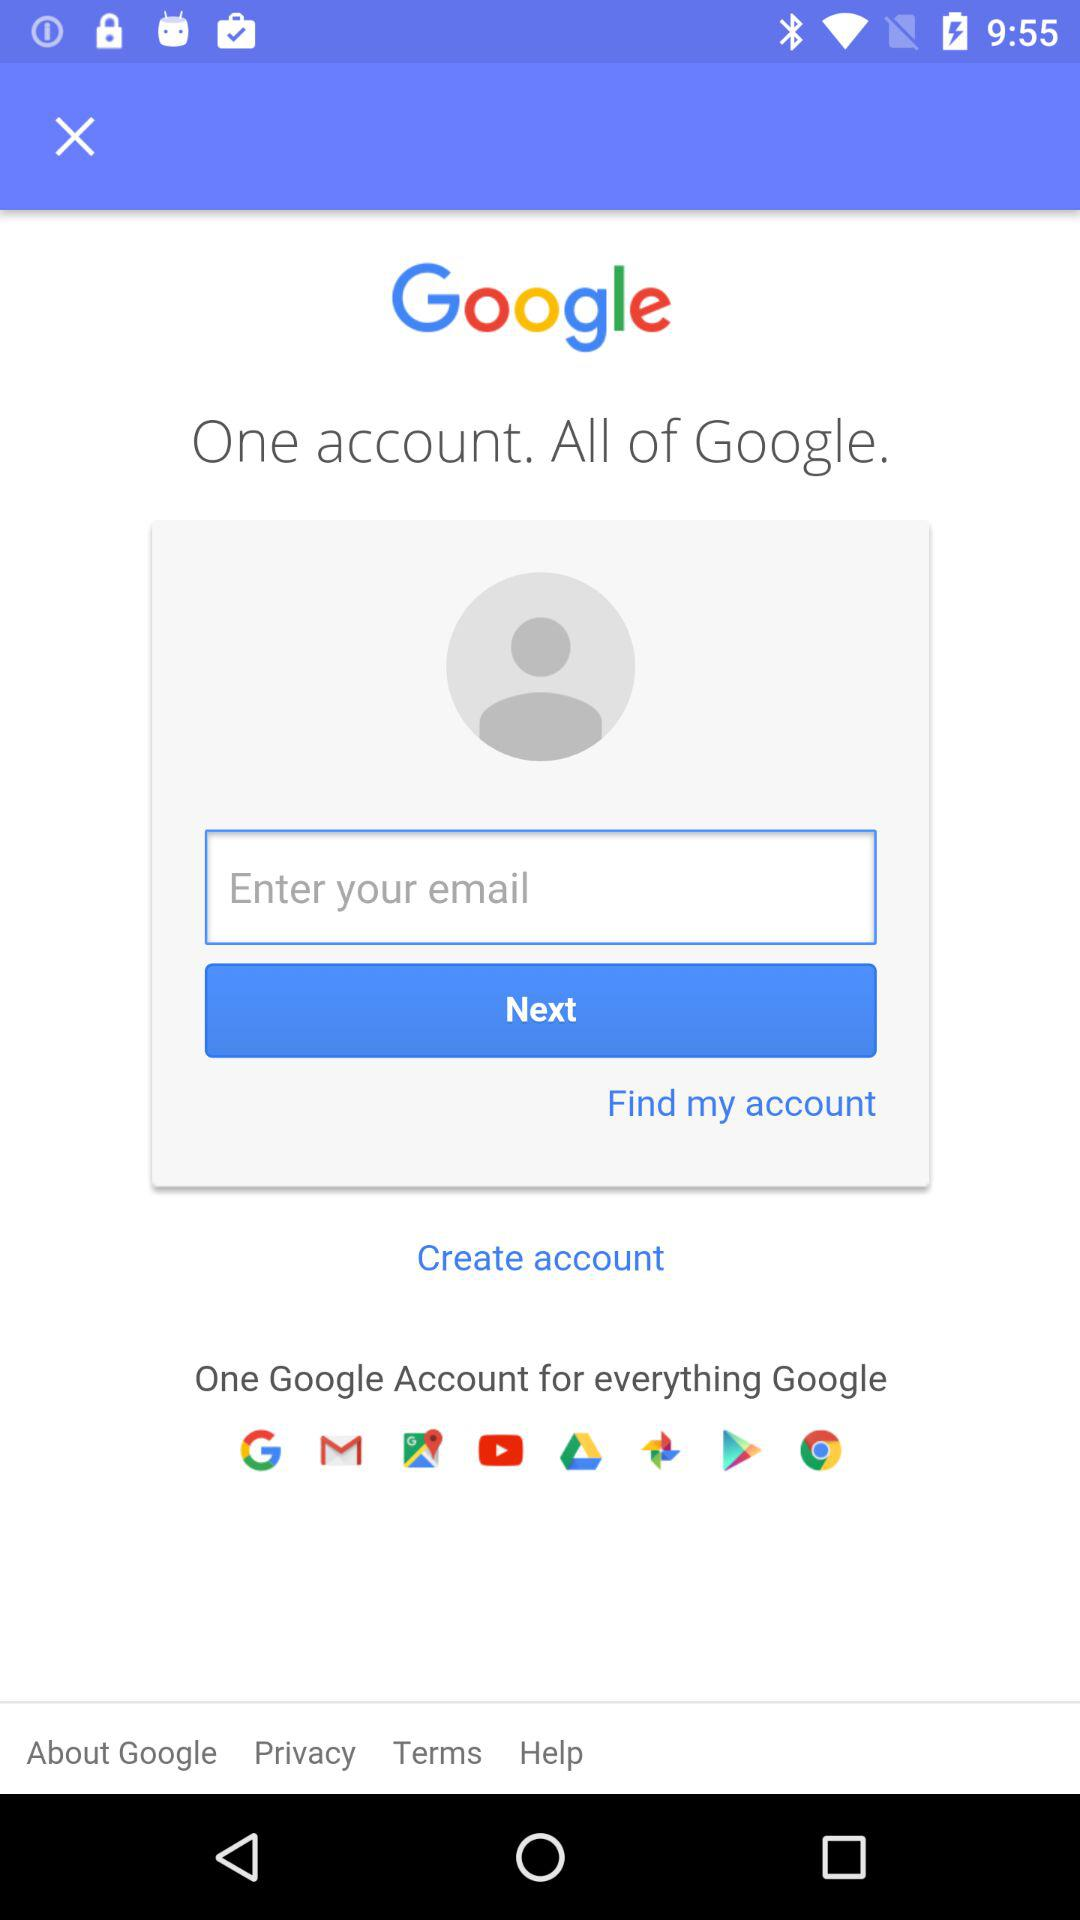What is the application name? The application name is "Google". 